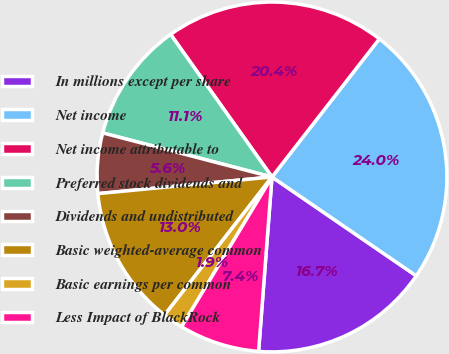<chart> <loc_0><loc_0><loc_500><loc_500><pie_chart><fcel>In millions except per share<fcel>Net income<fcel>Net income attributable to<fcel>Preferred stock dividends and<fcel>Dividends and undistributed<fcel>Basic weighted-average common<fcel>Basic earnings per common<fcel>Less Impact of BlackRock<nl><fcel>16.66%<fcel>24.04%<fcel>20.35%<fcel>11.11%<fcel>5.57%<fcel>12.96%<fcel>1.88%<fcel>7.42%<nl></chart> 